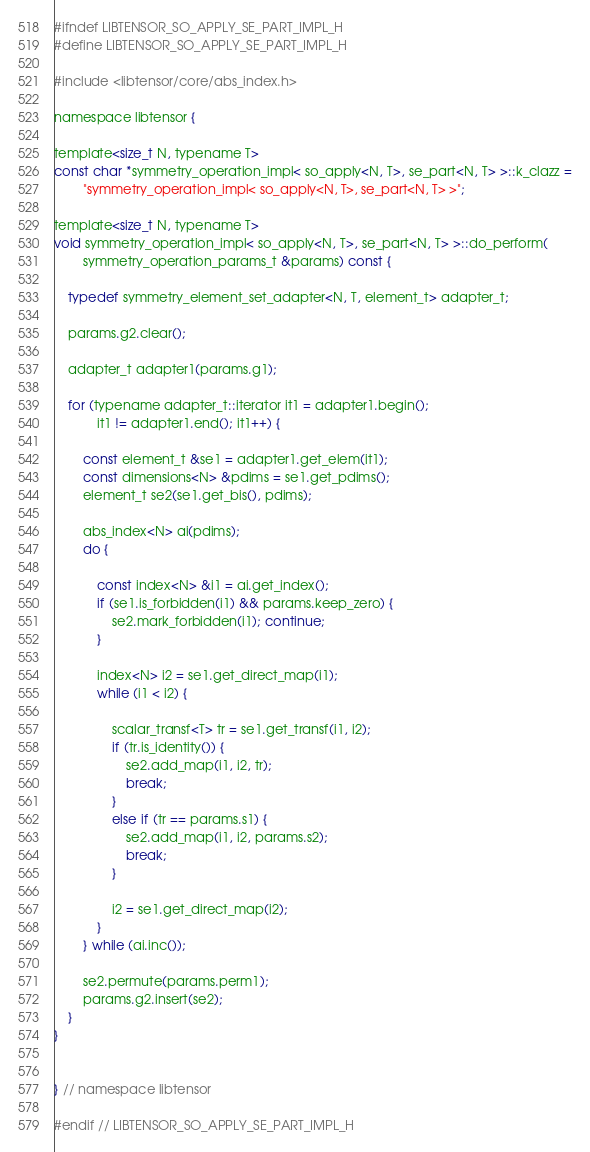<code> <loc_0><loc_0><loc_500><loc_500><_C_>#ifndef LIBTENSOR_SO_APPLY_SE_PART_IMPL_H
#define LIBTENSOR_SO_APPLY_SE_PART_IMPL_H

#include <libtensor/core/abs_index.h>

namespace libtensor {

template<size_t N, typename T>
const char *symmetry_operation_impl< so_apply<N, T>, se_part<N, T> >::k_clazz =
        "symmetry_operation_impl< so_apply<N, T>, se_part<N, T> >";

template<size_t N, typename T>
void symmetry_operation_impl< so_apply<N, T>, se_part<N, T> >::do_perform(
        symmetry_operation_params_t &params) const {

    typedef symmetry_element_set_adapter<N, T, element_t> adapter_t;

    params.g2.clear();

    adapter_t adapter1(params.g1);

    for (typename adapter_t::iterator it1 = adapter1.begin();
            it1 != adapter1.end(); it1++) {

        const element_t &se1 = adapter1.get_elem(it1);
        const dimensions<N> &pdims = se1.get_pdims();
        element_t se2(se1.get_bis(), pdims);

        abs_index<N> ai(pdims);
        do {

            const index<N> &i1 = ai.get_index();
            if (se1.is_forbidden(i1) && params.keep_zero) {
                se2.mark_forbidden(i1); continue;
            }

            index<N> i2 = se1.get_direct_map(i1);
            while (i1 < i2) {

                scalar_transf<T> tr = se1.get_transf(i1, i2);
                if (tr.is_identity()) {
                    se2.add_map(i1, i2, tr);
                    break;
                }
                else if (tr == params.s1) {
                    se2.add_map(i1, i2, params.s2);
                    break;
                }

                i2 = se1.get_direct_map(i2);
            }
        } while (ai.inc());

        se2.permute(params.perm1);
        params.g2.insert(se2);
    }
}


} // namespace libtensor

#endif // LIBTENSOR_SO_APPLY_SE_PART_IMPL_H
</code> 